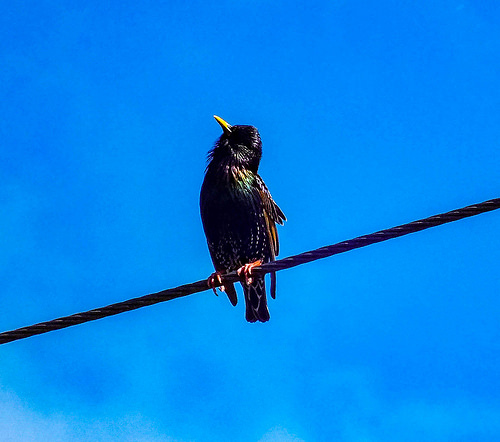<image>
Can you confirm if the bird is on the wire? Yes. Looking at the image, I can see the bird is positioned on top of the wire, with the wire providing support. Where is the crow in relation to the wire? Is it next to the wire? No. The crow is not positioned next to the wire. They are located in different areas of the scene. 